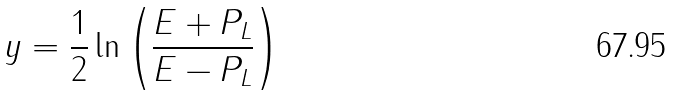<formula> <loc_0><loc_0><loc_500><loc_500>y = \frac { 1 } { 2 } \ln \left ( \frac { E + P _ { L } } { E - P _ { L } } \right )</formula> 